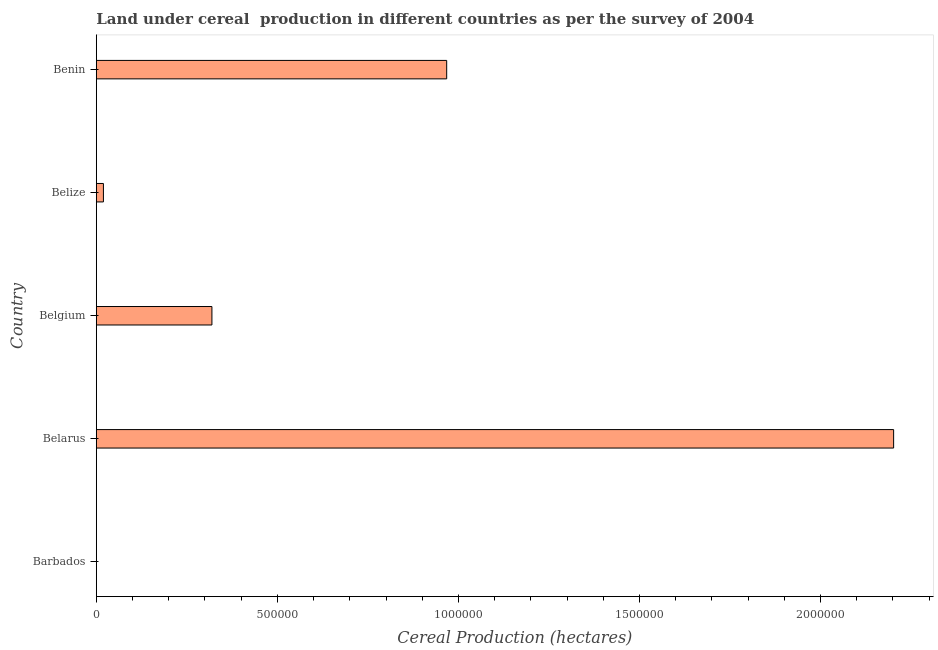Does the graph contain any zero values?
Keep it short and to the point. No. What is the title of the graph?
Your answer should be compact. Land under cereal  production in different countries as per the survey of 2004. What is the label or title of the X-axis?
Keep it short and to the point. Cereal Production (hectares). What is the label or title of the Y-axis?
Give a very brief answer. Country. What is the land under cereal production in Belgium?
Offer a very short reply. 3.19e+05. Across all countries, what is the maximum land under cereal production?
Give a very brief answer. 2.20e+06. Across all countries, what is the minimum land under cereal production?
Ensure brevity in your answer.  94. In which country was the land under cereal production maximum?
Ensure brevity in your answer.  Belarus. In which country was the land under cereal production minimum?
Make the answer very short. Barbados. What is the sum of the land under cereal production?
Your response must be concise. 3.51e+06. What is the difference between the land under cereal production in Belarus and Belize?
Your answer should be very brief. 2.18e+06. What is the average land under cereal production per country?
Offer a terse response. 7.02e+05. What is the median land under cereal production?
Offer a terse response. 3.19e+05. In how many countries, is the land under cereal production greater than 1100000 hectares?
Keep it short and to the point. 1. What is the ratio of the land under cereal production in Barbados to that in Belarus?
Your answer should be compact. 0. Is the land under cereal production in Barbados less than that in Belize?
Provide a succinct answer. Yes. Is the difference between the land under cereal production in Belgium and Belize greater than the difference between any two countries?
Provide a succinct answer. No. What is the difference between the highest and the second highest land under cereal production?
Your answer should be compact. 1.23e+06. What is the difference between the highest and the lowest land under cereal production?
Offer a very short reply. 2.20e+06. In how many countries, is the land under cereal production greater than the average land under cereal production taken over all countries?
Your answer should be very brief. 2. Are all the bars in the graph horizontal?
Your answer should be compact. Yes. How many countries are there in the graph?
Offer a very short reply. 5. What is the Cereal Production (hectares) of Barbados?
Give a very brief answer. 94. What is the Cereal Production (hectares) in Belarus?
Your answer should be compact. 2.20e+06. What is the Cereal Production (hectares) of Belgium?
Ensure brevity in your answer.  3.19e+05. What is the Cereal Production (hectares) in Belize?
Your answer should be very brief. 1.96e+04. What is the Cereal Production (hectares) of Benin?
Provide a short and direct response. 9.68e+05. What is the difference between the Cereal Production (hectares) in Barbados and Belarus?
Your answer should be very brief. -2.20e+06. What is the difference between the Cereal Production (hectares) in Barbados and Belgium?
Your answer should be very brief. -3.19e+05. What is the difference between the Cereal Production (hectares) in Barbados and Belize?
Give a very brief answer. -1.95e+04. What is the difference between the Cereal Production (hectares) in Barbados and Benin?
Offer a very short reply. -9.68e+05. What is the difference between the Cereal Production (hectares) in Belarus and Belgium?
Provide a succinct answer. 1.88e+06. What is the difference between the Cereal Production (hectares) in Belarus and Belize?
Give a very brief answer. 2.18e+06. What is the difference between the Cereal Production (hectares) in Belarus and Benin?
Make the answer very short. 1.23e+06. What is the difference between the Cereal Production (hectares) in Belgium and Belize?
Your answer should be compact. 3.00e+05. What is the difference between the Cereal Production (hectares) in Belgium and Benin?
Give a very brief answer. -6.48e+05. What is the difference between the Cereal Production (hectares) in Belize and Benin?
Your answer should be compact. -9.48e+05. What is the ratio of the Cereal Production (hectares) in Barbados to that in Belgium?
Ensure brevity in your answer.  0. What is the ratio of the Cereal Production (hectares) in Barbados to that in Belize?
Your response must be concise. 0.01. What is the ratio of the Cereal Production (hectares) in Belarus to that in Belgium?
Your response must be concise. 6.9. What is the ratio of the Cereal Production (hectares) in Belarus to that in Belize?
Provide a short and direct response. 112.58. What is the ratio of the Cereal Production (hectares) in Belarus to that in Benin?
Your answer should be compact. 2.28. What is the ratio of the Cereal Production (hectares) in Belgium to that in Belize?
Ensure brevity in your answer.  16.32. What is the ratio of the Cereal Production (hectares) in Belgium to that in Benin?
Offer a very short reply. 0.33. What is the ratio of the Cereal Production (hectares) in Belize to that in Benin?
Provide a short and direct response. 0.02. 